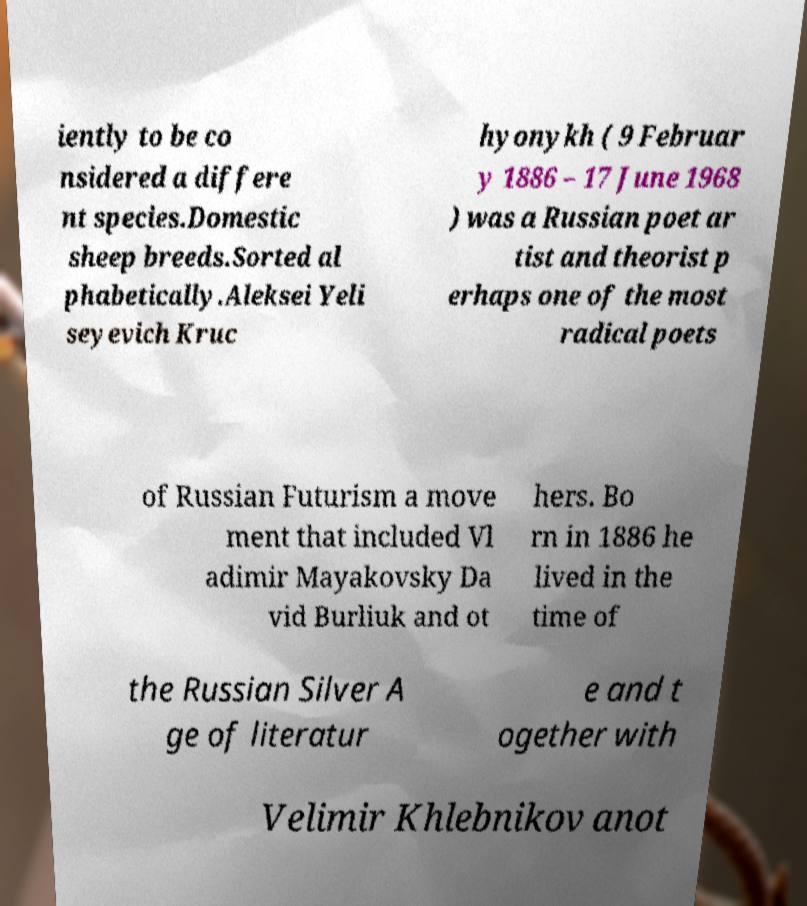There's text embedded in this image that I need extracted. Can you transcribe it verbatim? iently to be co nsidered a differe nt species.Domestic sheep breeds.Sorted al phabetically.Aleksei Yeli seyevich Kruc hyonykh ( 9 Februar y 1886 – 17 June 1968 ) was a Russian poet ar tist and theorist p erhaps one of the most radical poets of Russian Futurism a move ment that included Vl adimir Mayakovsky Da vid Burliuk and ot hers. Bo rn in 1886 he lived in the time of the Russian Silver A ge of literatur e and t ogether with Velimir Khlebnikov anot 